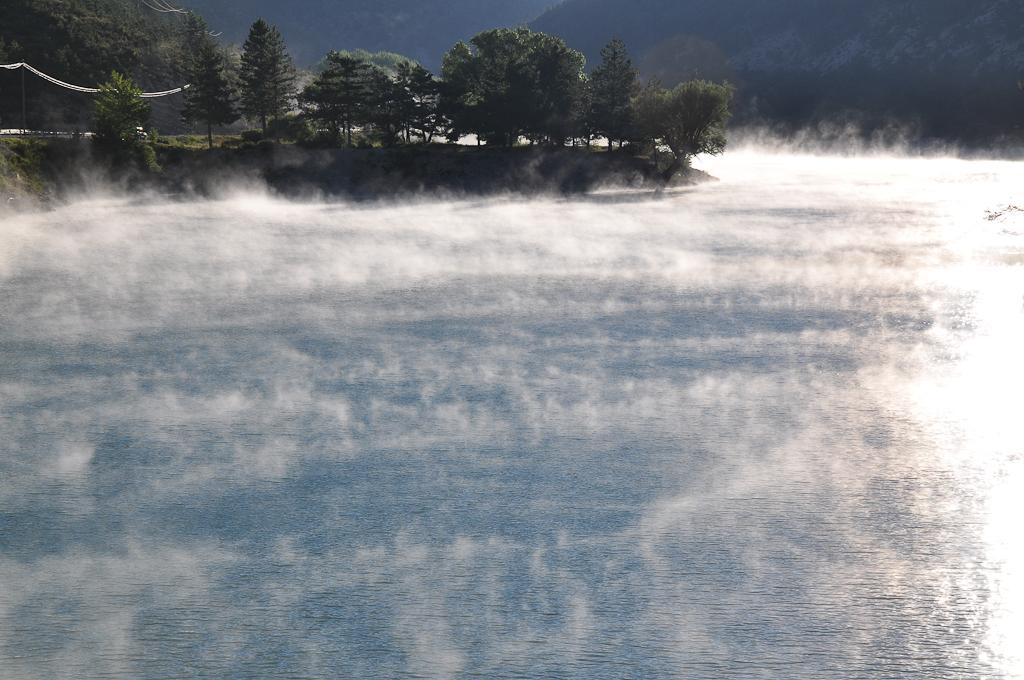What type of body of water is present in the image? There is a lake in the image. What is the weather like in the image? There is snow visible in the image, indicating a cold or wintery environment. What type of vegetation can be seen in the image? There are trees in the image. What type of geographical feature is present in the background of the image? There are mountains in the image. What type of cream can be seen dripping from the trees in the image? There is no cream present in the image; it features a lake, snow, trees, and mountains. 